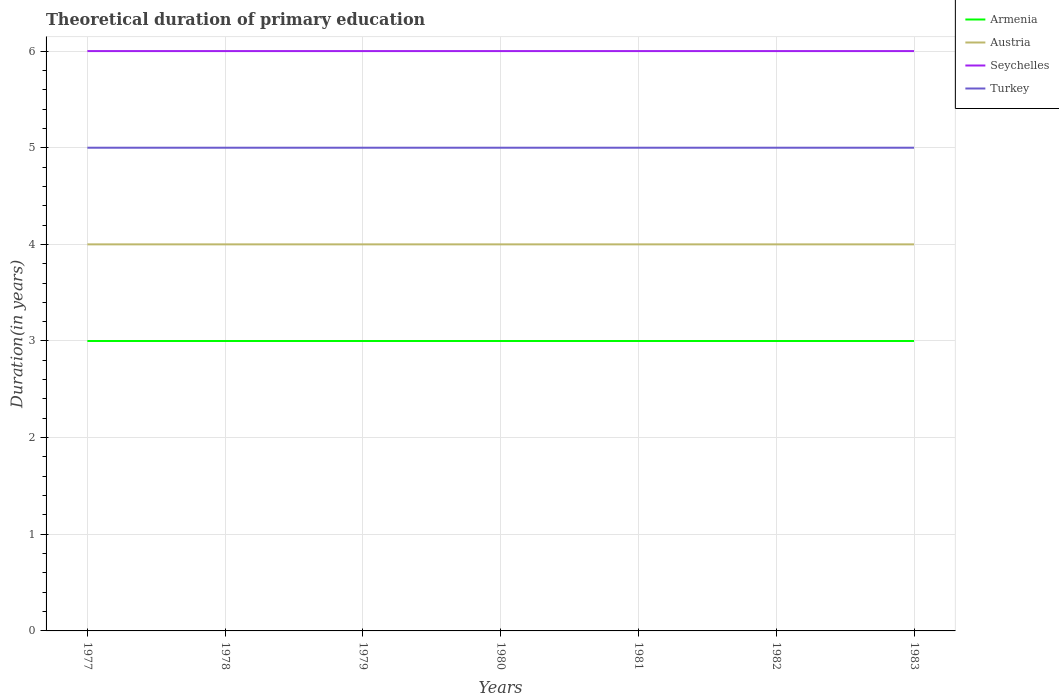How many different coloured lines are there?
Ensure brevity in your answer.  4. Across all years, what is the maximum total theoretical duration of primary education in Turkey?
Offer a very short reply. 5. In which year was the total theoretical duration of primary education in Austria maximum?
Ensure brevity in your answer.  1977. What is the difference between the highest and the second highest total theoretical duration of primary education in Armenia?
Your response must be concise. 0. What is the difference between the highest and the lowest total theoretical duration of primary education in Armenia?
Ensure brevity in your answer.  0. Is the total theoretical duration of primary education in Turkey strictly greater than the total theoretical duration of primary education in Armenia over the years?
Your response must be concise. No. How many lines are there?
Give a very brief answer. 4. What is the difference between two consecutive major ticks on the Y-axis?
Keep it short and to the point. 1. Are the values on the major ticks of Y-axis written in scientific E-notation?
Your answer should be very brief. No. Does the graph contain any zero values?
Provide a short and direct response. No. Does the graph contain grids?
Provide a short and direct response. Yes. Where does the legend appear in the graph?
Your answer should be very brief. Top right. How are the legend labels stacked?
Offer a terse response. Vertical. What is the title of the graph?
Your answer should be very brief. Theoretical duration of primary education. What is the label or title of the Y-axis?
Give a very brief answer. Duration(in years). What is the Duration(in years) of Austria in 1977?
Give a very brief answer. 4. What is the Duration(in years) in Armenia in 1978?
Give a very brief answer. 3. What is the Duration(in years) of Seychelles in 1978?
Give a very brief answer. 6. What is the Duration(in years) of Turkey in 1978?
Give a very brief answer. 5. What is the Duration(in years) of Armenia in 1979?
Give a very brief answer. 3. What is the Duration(in years) of Seychelles in 1979?
Give a very brief answer. 6. What is the Duration(in years) of Turkey in 1979?
Keep it short and to the point. 5. What is the Duration(in years) of Seychelles in 1980?
Provide a succinct answer. 6. What is the Duration(in years) of Turkey in 1980?
Your response must be concise. 5. What is the Duration(in years) of Armenia in 1982?
Offer a terse response. 3. What is the Duration(in years) of Seychelles in 1982?
Give a very brief answer. 6. What is the Duration(in years) of Armenia in 1983?
Give a very brief answer. 3. What is the Duration(in years) in Austria in 1983?
Give a very brief answer. 4. What is the Duration(in years) in Seychelles in 1983?
Your answer should be very brief. 6. What is the Duration(in years) in Turkey in 1983?
Your response must be concise. 5. Across all years, what is the maximum Duration(in years) of Seychelles?
Make the answer very short. 6. Across all years, what is the maximum Duration(in years) of Turkey?
Provide a short and direct response. 5. Across all years, what is the minimum Duration(in years) of Armenia?
Provide a succinct answer. 3. Across all years, what is the minimum Duration(in years) in Austria?
Keep it short and to the point. 4. What is the total Duration(in years) in Armenia in the graph?
Your response must be concise. 21. What is the total Duration(in years) of Seychelles in the graph?
Make the answer very short. 42. What is the difference between the Duration(in years) in Austria in 1977 and that in 1978?
Keep it short and to the point. 0. What is the difference between the Duration(in years) of Seychelles in 1977 and that in 1979?
Ensure brevity in your answer.  0. What is the difference between the Duration(in years) in Turkey in 1977 and that in 1980?
Keep it short and to the point. 0. What is the difference between the Duration(in years) of Austria in 1977 and that in 1981?
Provide a succinct answer. 0. What is the difference between the Duration(in years) in Austria in 1977 and that in 1982?
Your answer should be very brief. 0. What is the difference between the Duration(in years) of Turkey in 1977 and that in 1982?
Your answer should be compact. 0. What is the difference between the Duration(in years) of Austria in 1977 and that in 1983?
Make the answer very short. 0. What is the difference between the Duration(in years) of Armenia in 1978 and that in 1979?
Offer a terse response. 0. What is the difference between the Duration(in years) of Seychelles in 1978 and that in 1979?
Your response must be concise. 0. What is the difference between the Duration(in years) of Turkey in 1978 and that in 1979?
Provide a succinct answer. 0. What is the difference between the Duration(in years) in Armenia in 1978 and that in 1980?
Provide a short and direct response. 0. What is the difference between the Duration(in years) in Seychelles in 1978 and that in 1980?
Provide a short and direct response. 0. What is the difference between the Duration(in years) of Austria in 1978 and that in 1981?
Provide a short and direct response. 0. What is the difference between the Duration(in years) in Seychelles in 1978 and that in 1981?
Offer a terse response. 0. What is the difference between the Duration(in years) in Armenia in 1978 and that in 1982?
Offer a terse response. 0. What is the difference between the Duration(in years) of Turkey in 1978 and that in 1982?
Make the answer very short. 0. What is the difference between the Duration(in years) of Armenia in 1978 and that in 1983?
Make the answer very short. 0. What is the difference between the Duration(in years) of Austria in 1978 and that in 1983?
Provide a short and direct response. 0. What is the difference between the Duration(in years) of Seychelles in 1978 and that in 1983?
Keep it short and to the point. 0. What is the difference between the Duration(in years) in Turkey in 1978 and that in 1983?
Ensure brevity in your answer.  0. What is the difference between the Duration(in years) in Armenia in 1979 and that in 1980?
Offer a terse response. 0. What is the difference between the Duration(in years) of Seychelles in 1979 and that in 1980?
Your response must be concise. 0. What is the difference between the Duration(in years) of Turkey in 1979 and that in 1981?
Your answer should be very brief. 0. What is the difference between the Duration(in years) in Armenia in 1979 and that in 1982?
Offer a very short reply. 0. What is the difference between the Duration(in years) in Armenia in 1979 and that in 1983?
Your answer should be compact. 0. What is the difference between the Duration(in years) of Austria in 1979 and that in 1983?
Provide a succinct answer. 0. What is the difference between the Duration(in years) of Turkey in 1979 and that in 1983?
Your answer should be very brief. 0. What is the difference between the Duration(in years) of Austria in 1980 and that in 1981?
Your answer should be compact. 0. What is the difference between the Duration(in years) of Seychelles in 1980 and that in 1981?
Ensure brevity in your answer.  0. What is the difference between the Duration(in years) in Armenia in 1980 and that in 1982?
Make the answer very short. 0. What is the difference between the Duration(in years) of Seychelles in 1980 and that in 1982?
Your response must be concise. 0. What is the difference between the Duration(in years) in Austria in 1980 and that in 1983?
Your answer should be very brief. 0. What is the difference between the Duration(in years) in Turkey in 1980 and that in 1983?
Make the answer very short. 0. What is the difference between the Duration(in years) in Armenia in 1981 and that in 1982?
Make the answer very short. 0. What is the difference between the Duration(in years) of Austria in 1981 and that in 1982?
Keep it short and to the point. 0. What is the difference between the Duration(in years) in Seychelles in 1981 and that in 1982?
Your answer should be very brief. 0. What is the difference between the Duration(in years) of Turkey in 1981 and that in 1982?
Your response must be concise. 0. What is the difference between the Duration(in years) of Armenia in 1981 and that in 1983?
Your answer should be very brief. 0. What is the difference between the Duration(in years) of Austria in 1981 and that in 1983?
Your response must be concise. 0. What is the difference between the Duration(in years) of Armenia in 1982 and that in 1983?
Offer a terse response. 0. What is the difference between the Duration(in years) of Seychelles in 1982 and that in 1983?
Give a very brief answer. 0. What is the difference between the Duration(in years) of Armenia in 1977 and the Duration(in years) of Seychelles in 1978?
Your answer should be very brief. -3. What is the difference between the Duration(in years) in Austria in 1977 and the Duration(in years) in Turkey in 1978?
Offer a very short reply. -1. What is the difference between the Duration(in years) of Austria in 1977 and the Duration(in years) of Turkey in 1979?
Your answer should be compact. -1. What is the difference between the Duration(in years) in Seychelles in 1977 and the Duration(in years) in Turkey in 1979?
Ensure brevity in your answer.  1. What is the difference between the Duration(in years) in Austria in 1977 and the Duration(in years) in Seychelles in 1980?
Your answer should be very brief. -2. What is the difference between the Duration(in years) in Austria in 1977 and the Duration(in years) in Turkey in 1980?
Offer a very short reply. -1. What is the difference between the Duration(in years) of Armenia in 1977 and the Duration(in years) of Turkey in 1981?
Offer a very short reply. -2. What is the difference between the Duration(in years) of Armenia in 1977 and the Duration(in years) of Seychelles in 1982?
Offer a very short reply. -3. What is the difference between the Duration(in years) of Armenia in 1977 and the Duration(in years) of Turkey in 1982?
Offer a terse response. -2. What is the difference between the Duration(in years) of Austria in 1977 and the Duration(in years) of Turkey in 1982?
Your answer should be very brief. -1. What is the difference between the Duration(in years) of Seychelles in 1977 and the Duration(in years) of Turkey in 1983?
Keep it short and to the point. 1. What is the difference between the Duration(in years) in Armenia in 1978 and the Duration(in years) in Turkey in 1979?
Your answer should be very brief. -2. What is the difference between the Duration(in years) in Austria in 1978 and the Duration(in years) in Seychelles in 1979?
Give a very brief answer. -2. What is the difference between the Duration(in years) of Austria in 1978 and the Duration(in years) of Turkey in 1979?
Give a very brief answer. -1. What is the difference between the Duration(in years) in Armenia in 1978 and the Duration(in years) in Turkey in 1980?
Offer a terse response. -2. What is the difference between the Duration(in years) in Austria in 1978 and the Duration(in years) in Seychelles in 1980?
Your answer should be compact. -2. What is the difference between the Duration(in years) of Seychelles in 1978 and the Duration(in years) of Turkey in 1980?
Provide a succinct answer. 1. What is the difference between the Duration(in years) in Armenia in 1978 and the Duration(in years) in Austria in 1981?
Ensure brevity in your answer.  -1. What is the difference between the Duration(in years) of Armenia in 1978 and the Duration(in years) of Seychelles in 1981?
Your answer should be compact. -3. What is the difference between the Duration(in years) of Austria in 1978 and the Duration(in years) of Seychelles in 1981?
Make the answer very short. -2. What is the difference between the Duration(in years) of Armenia in 1978 and the Duration(in years) of Seychelles in 1982?
Ensure brevity in your answer.  -3. What is the difference between the Duration(in years) in Austria in 1978 and the Duration(in years) in Seychelles in 1982?
Provide a succinct answer. -2. What is the difference between the Duration(in years) of Austria in 1978 and the Duration(in years) of Turkey in 1982?
Your answer should be compact. -1. What is the difference between the Duration(in years) of Armenia in 1978 and the Duration(in years) of Seychelles in 1983?
Offer a very short reply. -3. What is the difference between the Duration(in years) in Armenia in 1979 and the Duration(in years) in Seychelles in 1980?
Provide a succinct answer. -3. What is the difference between the Duration(in years) of Armenia in 1979 and the Duration(in years) of Turkey in 1980?
Offer a terse response. -2. What is the difference between the Duration(in years) of Austria in 1979 and the Duration(in years) of Seychelles in 1980?
Your response must be concise. -2. What is the difference between the Duration(in years) of Armenia in 1979 and the Duration(in years) of Austria in 1981?
Provide a short and direct response. -1. What is the difference between the Duration(in years) in Armenia in 1979 and the Duration(in years) in Seychelles in 1981?
Provide a succinct answer. -3. What is the difference between the Duration(in years) in Armenia in 1979 and the Duration(in years) in Turkey in 1981?
Provide a succinct answer. -2. What is the difference between the Duration(in years) in Austria in 1979 and the Duration(in years) in Turkey in 1981?
Ensure brevity in your answer.  -1. What is the difference between the Duration(in years) of Austria in 1979 and the Duration(in years) of Seychelles in 1982?
Your answer should be very brief. -2. What is the difference between the Duration(in years) of Armenia in 1979 and the Duration(in years) of Seychelles in 1983?
Your answer should be very brief. -3. What is the difference between the Duration(in years) in Armenia in 1979 and the Duration(in years) in Turkey in 1983?
Your answer should be compact. -2. What is the difference between the Duration(in years) of Austria in 1979 and the Duration(in years) of Turkey in 1983?
Ensure brevity in your answer.  -1. What is the difference between the Duration(in years) of Armenia in 1980 and the Duration(in years) of Seychelles in 1981?
Your answer should be very brief. -3. What is the difference between the Duration(in years) in Armenia in 1980 and the Duration(in years) in Turkey in 1981?
Your response must be concise. -2. What is the difference between the Duration(in years) of Austria in 1980 and the Duration(in years) of Seychelles in 1981?
Make the answer very short. -2. What is the difference between the Duration(in years) of Armenia in 1980 and the Duration(in years) of Austria in 1982?
Ensure brevity in your answer.  -1. What is the difference between the Duration(in years) of Austria in 1980 and the Duration(in years) of Turkey in 1982?
Offer a terse response. -1. What is the difference between the Duration(in years) in Seychelles in 1980 and the Duration(in years) in Turkey in 1982?
Ensure brevity in your answer.  1. What is the difference between the Duration(in years) of Armenia in 1980 and the Duration(in years) of Austria in 1983?
Give a very brief answer. -1. What is the difference between the Duration(in years) in Armenia in 1980 and the Duration(in years) in Seychelles in 1983?
Offer a terse response. -3. What is the difference between the Duration(in years) in Austria in 1980 and the Duration(in years) in Seychelles in 1983?
Your response must be concise. -2. What is the difference between the Duration(in years) in Seychelles in 1980 and the Duration(in years) in Turkey in 1983?
Keep it short and to the point. 1. What is the difference between the Duration(in years) of Armenia in 1981 and the Duration(in years) of Seychelles in 1982?
Provide a succinct answer. -3. What is the difference between the Duration(in years) in Austria in 1981 and the Duration(in years) in Seychelles in 1982?
Your response must be concise. -2. What is the difference between the Duration(in years) in Austria in 1981 and the Duration(in years) in Turkey in 1982?
Make the answer very short. -1. What is the difference between the Duration(in years) in Seychelles in 1981 and the Duration(in years) in Turkey in 1982?
Give a very brief answer. 1. What is the difference between the Duration(in years) in Armenia in 1981 and the Duration(in years) in Turkey in 1983?
Your answer should be compact. -2. What is the difference between the Duration(in years) of Austria in 1981 and the Duration(in years) of Turkey in 1983?
Offer a terse response. -1. What is the difference between the Duration(in years) in Seychelles in 1981 and the Duration(in years) in Turkey in 1983?
Your answer should be very brief. 1. What is the difference between the Duration(in years) in Armenia in 1982 and the Duration(in years) in Austria in 1983?
Offer a very short reply. -1. What is the difference between the Duration(in years) in Armenia in 1982 and the Duration(in years) in Turkey in 1983?
Give a very brief answer. -2. What is the difference between the Duration(in years) in Austria in 1982 and the Duration(in years) in Seychelles in 1983?
Provide a short and direct response. -2. What is the difference between the Duration(in years) in Austria in 1982 and the Duration(in years) in Turkey in 1983?
Your answer should be compact. -1. What is the average Duration(in years) of Armenia per year?
Make the answer very short. 3. What is the average Duration(in years) in Seychelles per year?
Keep it short and to the point. 6. What is the average Duration(in years) in Turkey per year?
Your answer should be compact. 5. In the year 1977, what is the difference between the Duration(in years) of Armenia and Duration(in years) of Austria?
Keep it short and to the point. -1. In the year 1977, what is the difference between the Duration(in years) of Armenia and Duration(in years) of Seychelles?
Your answer should be very brief. -3. In the year 1977, what is the difference between the Duration(in years) in Armenia and Duration(in years) in Turkey?
Keep it short and to the point. -2. In the year 1977, what is the difference between the Duration(in years) in Austria and Duration(in years) in Seychelles?
Your answer should be compact. -2. In the year 1977, what is the difference between the Duration(in years) of Austria and Duration(in years) of Turkey?
Provide a succinct answer. -1. In the year 1978, what is the difference between the Duration(in years) of Armenia and Duration(in years) of Seychelles?
Your response must be concise. -3. In the year 1978, what is the difference between the Duration(in years) of Austria and Duration(in years) of Seychelles?
Ensure brevity in your answer.  -2. In the year 1979, what is the difference between the Duration(in years) of Armenia and Duration(in years) of Seychelles?
Keep it short and to the point. -3. In the year 1979, what is the difference between the Duration(in years) in Austria and Duration(in years) in Turkey?
Provide a short and direct response. -1. In the year 1979, what is the difference between the Duration(in years) of Seychelles and Duration(in years) of Turkey?
Give a very brief answer. 1. In the year 1980, what is the difference between the Duration(in years) of Armenia and Duration(in years) of Austria?
Your response must be concise. -1. In the year 1980, what is the difference between the Duration(in years) in Armenia and Duration(in years) in Turkey?
Provide a succinct answer. -2. In the year 1980, what is the difference between the Duration(in years) in Seychelles and Duration(in years) in Turkey?
Make the answer very short. 1. In the year 1981, what is the difference between the Duration(in years) of Armenia and Duration(in years) of Seychelles?
Offer a terse response. -3. In the year 1981, what is the difference between the Duration(in years) in Austria and Duration(in years) in Turkey?
Make the answer very short. -1. In the year 1982, what is the difference between the Duration(in years) of Armenia and Duration(in years) of Seychelles?
Give a very brief answer. -3. In the year 1982, what is the difference between the Duration(in years) of Armenia and Duration(in years) of Turkey?
Provide a succinct answer. -2. In the year 1982, what is the difference between the Duration(in years) of Austria and Duration(in years) of Turkey?
Your answer should be very brief. -1. In the year 1982, what is the difference between the Duration(in years) of Seychelles and Duration(in years) of Turkey?
Your answer should be compact. 1. In the year 1983, what is the difference between the Duration(in years) of Armenia and Duration(in years) of Austria?
Offer a very short reply. -1. In the year 1983, what is the difference between the Duration(in years) of Armenia and Duration(in years) of Seychelles?
Your answer should be very brief. -3. What is the ratio of the Duration(in years) of Armenia in 1977 to that in 1978?
Ensure brevity in your answer.  1. What is the ratio of the Duration(in years) in Turkey in 1977 to that in 1979?
Ensure brevity in your answer.  1. What is the ratio of the Duration(in years) in Armenia in 1977 to that in 1980?
Make the answer very short. 1. What is the ratio of the Duration(in years) in Austria in 1977 to that in 1980?
Ensure brevity in your answer.  1. What is the ratio of the Duration(in years) in Turkey in 1977 to that in 1980?
Ensure brevity in your answer.  1. What is the ratio of the Duration(in years) in Austria in 1977 to that in 1981?
Provide a succinct answer. 1. What is the ratio of the Duration(in years) in Seychelles in 1977 to that in 1981?
Provide a short and direct response. 1. What is the ratio of the Duration(in years) in Turkey in 1977 to that in 1981?
Your answer should be compact. 1. What is the ratio of the Duration(in years) of Turkey in 1977 to that in 1982?
Your answer should be compact. 1. What is the ratio of the Duration(in years) of Turkey in 1977 to that in 1983?
Keep it short and to the point. 1. What is the ratio of the Duration(in years) in Armenia in 1978 to that in 1979?
Provide a succinct answer. 1. What is the ratio of the Duration(in years) in Austria in 1978 to that in 1979?
Provide a short and direct response. 1. What is the ratio of the Duration(in years) of Seychelles in 1978 to that in 1979?
Ensure brevity in your answer.  1. What is the ratio of the Duration(in years) in Armenia in 1978 to that in 1981?
Keep it short and to the point. 1. What is the ratio of the Duration(in years) in Austria in 1978 to that in 1981?
Your answer should be very brief. 1. What is the ratio of the Duration(in years) of Turkey in 1978 to that in 1981?
Make the answer very short. 1. What is the ratio of the Duration(in years) in Armenia in 1978 to that in 1982?
Ensure brevity in your answer.  1. What is the ratio of the Duration(in years) of Seychelles in 1978 to that in 1982?
Give a very brief answer. 1. What is the ratio of the Duration(in years) of Turkey in 1978 to that in 1982?
Offer a terse response. 1. What is the ratio of the Duration(in years) of Turkey in 1978 to that in 1983?
Make the answer very short. 1. What is the ratio of the Duration(in years) of Austria in 1979 to that in 1980?
Your response must be concise. 1. What is the ratio of the Duration(in years) of Seychelles in 1979 to that in 1980?
Offer a very short reply. 1. What is the ratio of the Duration(in years) of Seychelles in 1979 to that in 1982?
Offer a terse response. 1. What is the ratio of the Duration(in years) in Armenia in 1979 to that in 1983?
Offer a terse response. 1. What is the ratio of the Duration(in years) in Turkey in 1979 to that in 1983?
Ensure brevity in your answer.  1. What is the ratio of the Duration(in years) of Austria in 1980 to that in 1981?
Offer a very short reply. 1. What is the ratio of the Duration(in years) in Turkey in 1980 to that in 1981?
Make the answer very short. 1. What is the ratio of the Duration(in years) of Armenia in 1980 to that in 1982?
Ensure brevity in your answer.  1. What is the ratio of the Duration(in years) of Austria in 1980 to that in 1982?
Your answer should be very brief. 1. What is the ratio of the Duration(in years) of Seychelles in 1980 to that in 1982?
Keep it short and to the point. 1. What is the ratio of the Duration(in years) of Turkey in 1980 to that in 1982?
Offer a very short reply. 1. What is the ratio of the Duration(in years) of Seychelles in 1981 to that in 1982?
Make the answer very short. 1. What is the ratio of the Duration(in years) in Armenia in 1981 to that in 1983?
Make the answer very short. 1. What is the ratio of the Duration(in years) in Seychelles in 1981 to that in 1983?
Keep it short and to the point. 1. What is the ratio of the Duration(in years) of Turkey in 1981 to that in 1983?
Your answer should be very brief. 1. What is the ratio of the Duration(in years) of Armenia in 1982 to that in 1983?
Make the answer very short. 1. What is the ratio of the Duration(in years) of Seychelles in 1982 to that in 1983?
Offer a terse response. 1. What is the difference between the highest and the second highest Duration(in years) in Austria?
Your response must be concise. 0. What is the difference between the highest and the second highest Duration(in years) in Turkey?
Provide a succinct answer. 0. What is the difference between the highest and the lowest Duration(in years) of Armenia?
Ensure brevity in your answer.  0. What is the difference between the highest and the lowest Duration(in years) of Austria?
Make the answer very short. 0. What is the difference between the highest and the lowest Duration(in years) of Seychelles?
Make the answer very short. 0. 